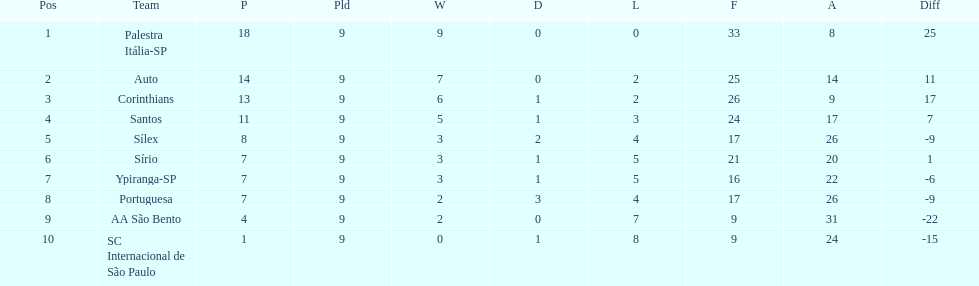Parse the full table. {'header': ['Pos', 'Team', 'P', 'Pld', 'W', 'D', 'L', 'F', 'A', 'Diff'], 'rows': [['1', 'Palestra Itália-SP', '18', '9', '9', '0', '0', '33', '8', '25'], ['2', 'Auto', '14', '9', '7', '0', '2', '25', '14', '11'], ['3', 'Corinthians', '13', '9', '6', '1', '2', '26', '9', '17'], ['4', 'Santos', '11', '9', '5', '1', '3', '24', '17', '7'], ['5', 'Sílex', '8', '9', '3', '2', '4', '17', '26', '-9'], ['6', 'Sírio', '7', '9', '3', '1', '5', '21', '20', '1'], ['7', 'Ypiranga-SP', '7', '9', '3', '1', '5', '16', '22', '-6'], ['8', 'Portuguesa', '7', '9', '2', '3', '4', '17', '26', '-9'], ['9', 'AA São Bento', '4', '9', '2', '0', '7', '9', '31', '-22'], ['10', 'SC Internacional de São Paulo', '1', '9', '0', '1', '8', '9', '24', '-15']]} Which team was the top scoring team? Palestra Itália-SP. 